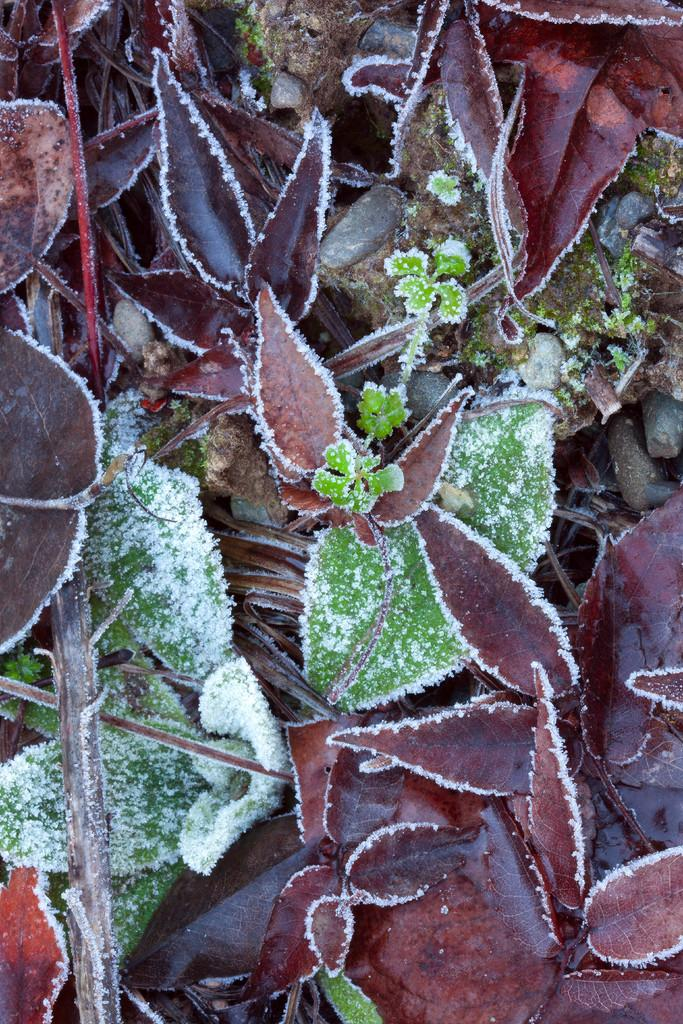What type of natural elements can be seen in the image? There are leaves in the image. What is the condition of the leaves in the image? The leaves are covered by snow. What type of plane can be seen flying over the leaves in the image? There is no plane visible in the image; it only features leaves covered by snow. What color is the scarf that the leaves are wearing in the image? There are no scarves present in the image, as it only features leaves covered by snow. 